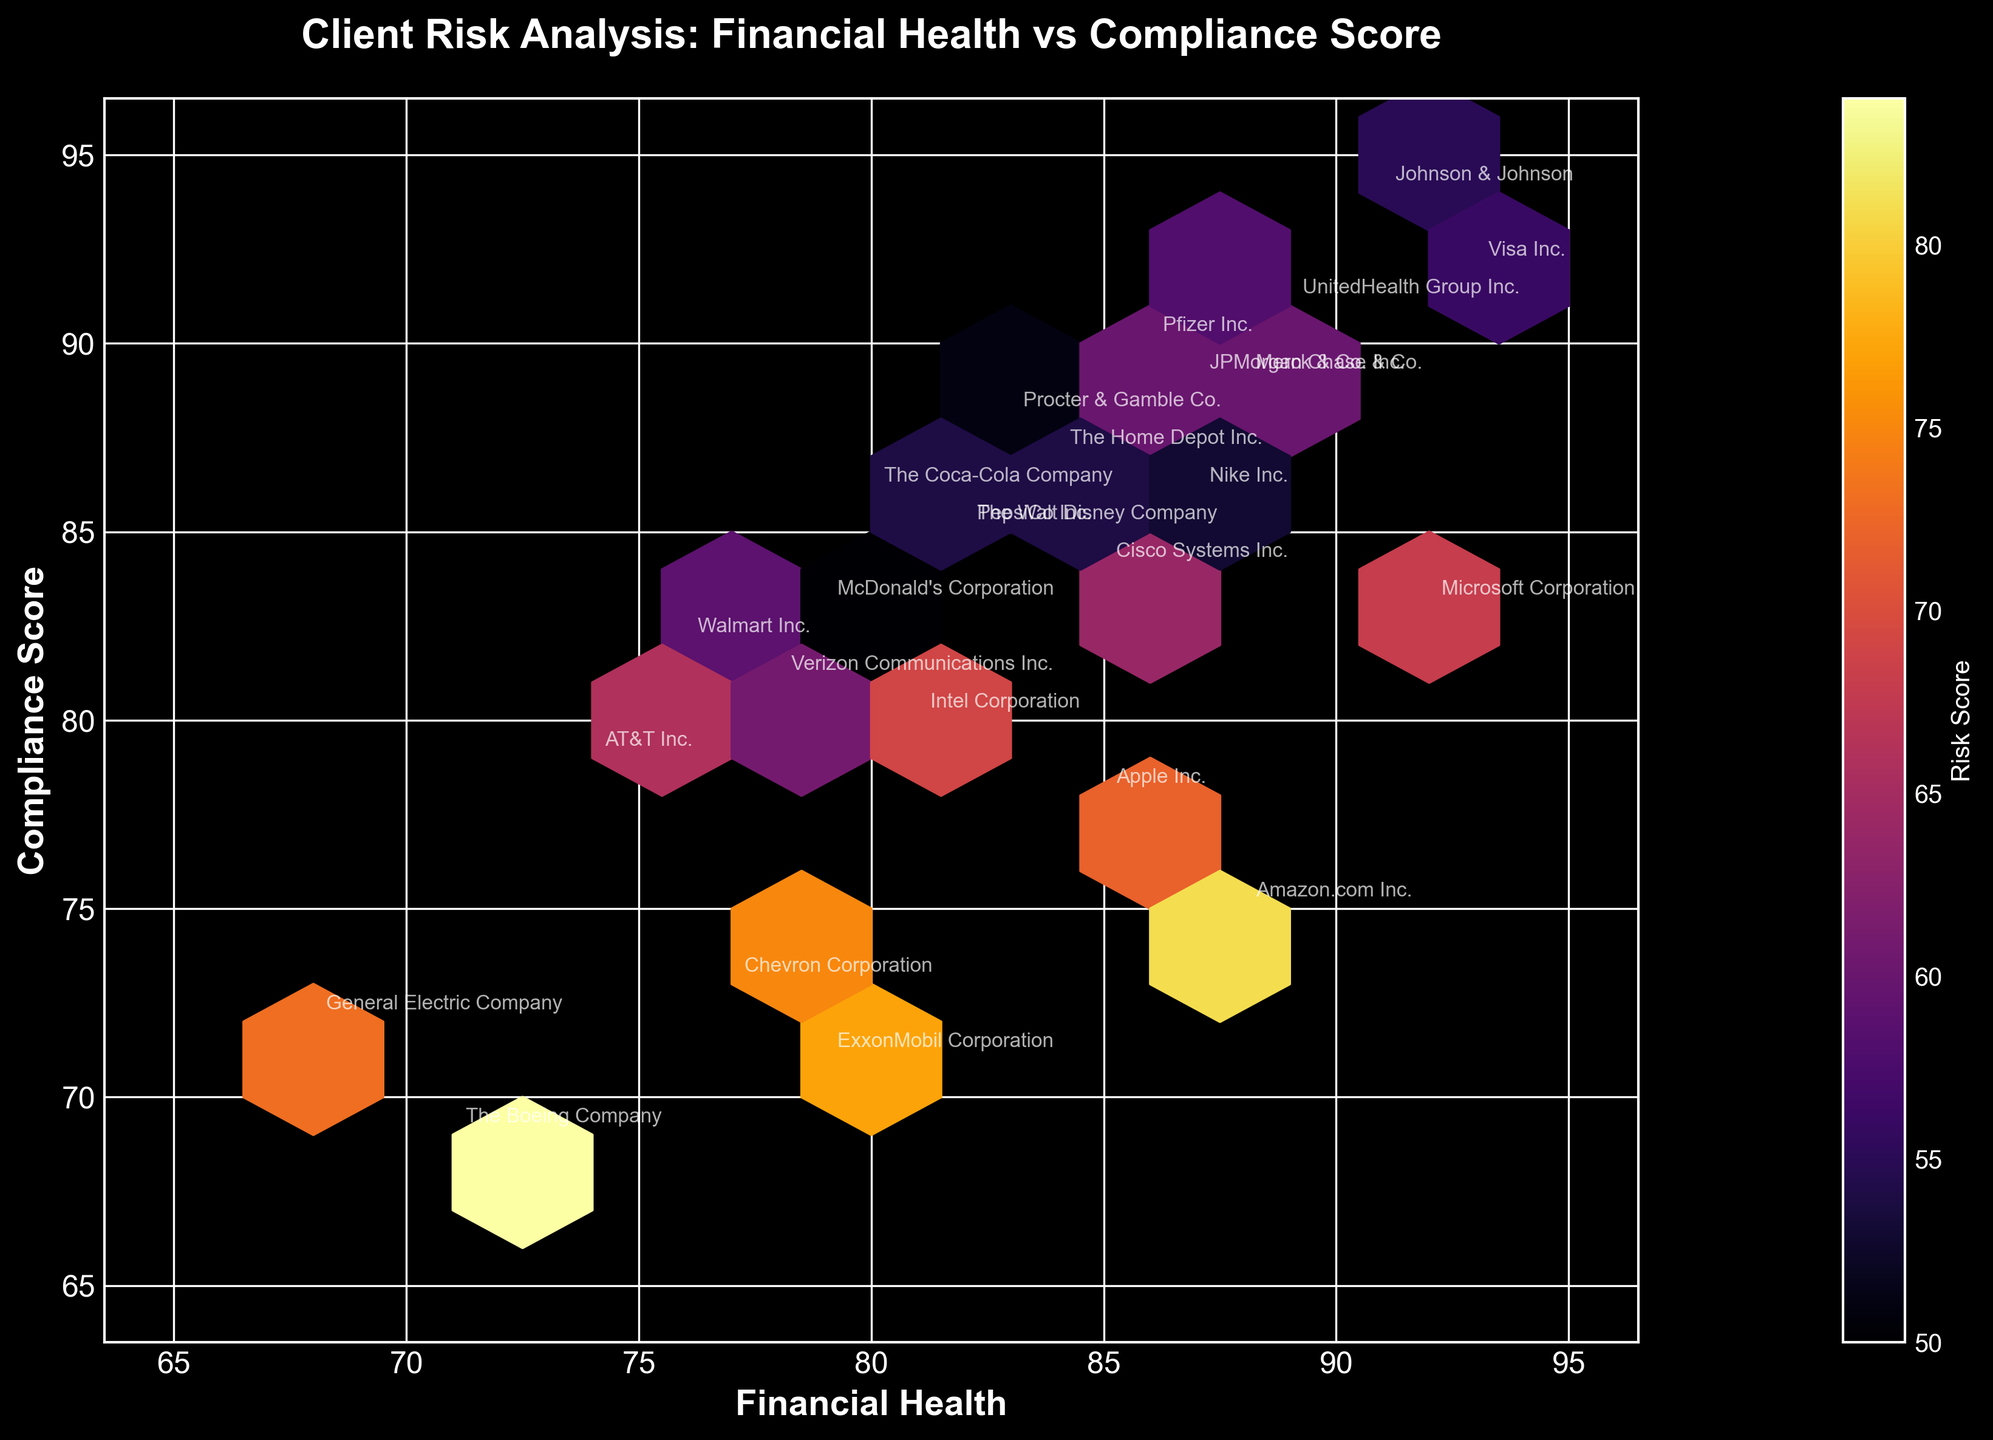What is the title of the figure? The title is usually placed at the top of the figure. It often explains what the figure is about in a concise manner. The title in this case is prominently displayed and reads "Client Risk Analysis: Financial Health vs Compliance Score".
Answer: Client Risk Analysis: Financial Health vs Compliance Score How many data points are shown in the figure? The number of data points is equal to the number of clients listed in the data. In the figure annotated with client names, we see 25 unique points, each corresponding to a different client.
Answer: 25 What is the color indicating in this figure? In a Hexbin Plot, the color often represents a third variable. Here, the color gradient is explained by the color bar which is labeled 'Risk Score'. Hence, the color indicates the level of risk score, with the color intensity changing based on the risk score value.
Answer: Risk Score Which company is located in the hexbin with the highest financial health and compliance score? By identifying the location on the axes, the hexbin containing the highest financial health and compliance score can be found. Visa Inc. is located at the coordinates (93, 92), making it the company with the highest values for both indicators.
Answer: Visa Inc What is the relationship between the financial health and compliance score of 'The Boeing Company'? By locating 'The Boeing Company' on the plot and noting its position on both axes, we can establish this relationship. 'The Boeing Company' is positioned where the financial health is 71 and the compliance score is 69, which are relatively lower in both dimensions compared to other companies.
Answer: Financial health: 71 and Compliance score: 69 Which two companies have the closest financial health and compliance scores? To determine the closest pairs, we need to visually identify which companies are nearest to each other. 'The Coca-Cola Company' and 'PepsiCo Inc.' are very close at coordinates around (80, 86) and (82, 85) respectively, showing minimal distances between their scores.
Answer: The Coca-Cola Company and PepsiCo Inc What is the average risk score of companies with financial health greater than 85? First, identify the companies with financial health values greater than 85 from the plot. These companies are Apple Inc., Microsoft Corporation, and Visa Inc. Summing their risk scores (72, 68, 56) and dividing by the number of companies (3) gives the average. (72 + 68 + 56) / 3 = 196 / 3 ≈ 65.33.
Answer: 65.33 Which company is outlier in terms of risk score when compared to its financial health and compliance score? Outliers can be detected by visual inspection of anomalies. 'The Boeing Company' stands out with a high risk score (84), yet it has lower financial health (71) and compliance score (69) in comparison to its peer companies.
Answer: The Boeing Company Are companies with higher compliance scores generally having higher risk scores? This can be assessed by analyzing the hexbin plot areas where compliance scores are high and checking the corresponding color intensities. In this plot, stronger colors (indicative of higher risk scores) are not consistently found in areas of higher compliance scores, suggesting no strong correlation.
Answer: No 